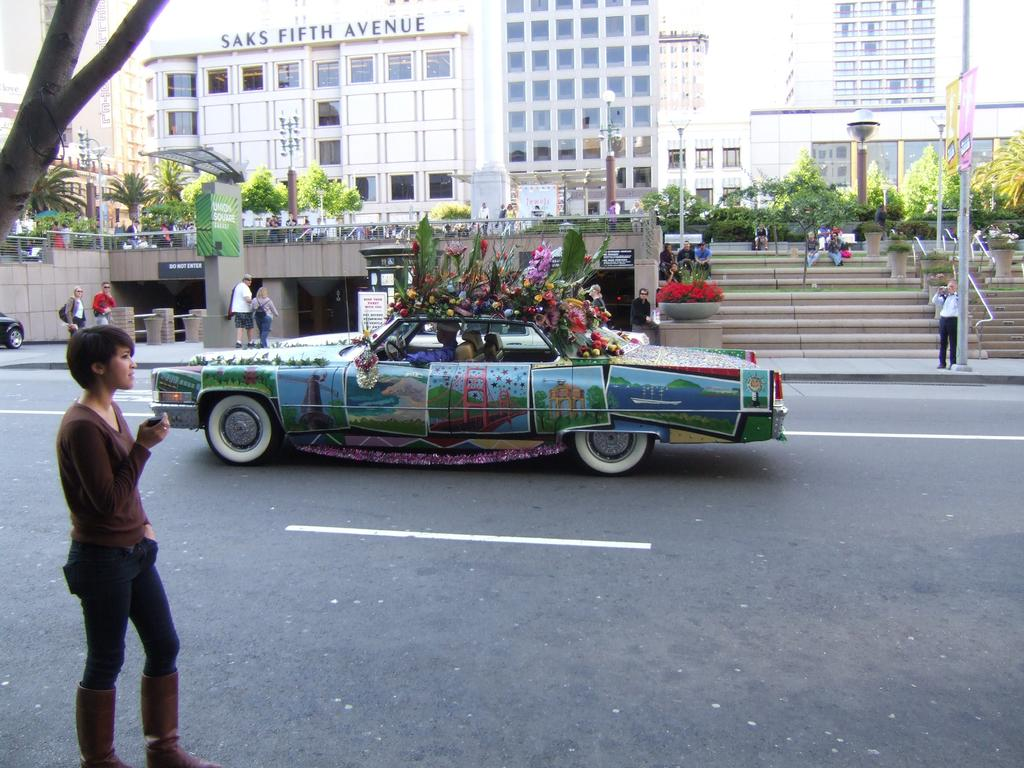What is the woman doing in the image? The woman is standing on the road in the image. What can be seen in the background behind the woman? There is a car, a person in the car, a building, the sky, and a tree visible in the background. What type of wax is being used by the spiders to build their webs in the image? There are no spiders or webs present in the image, so there is no wax being used. 